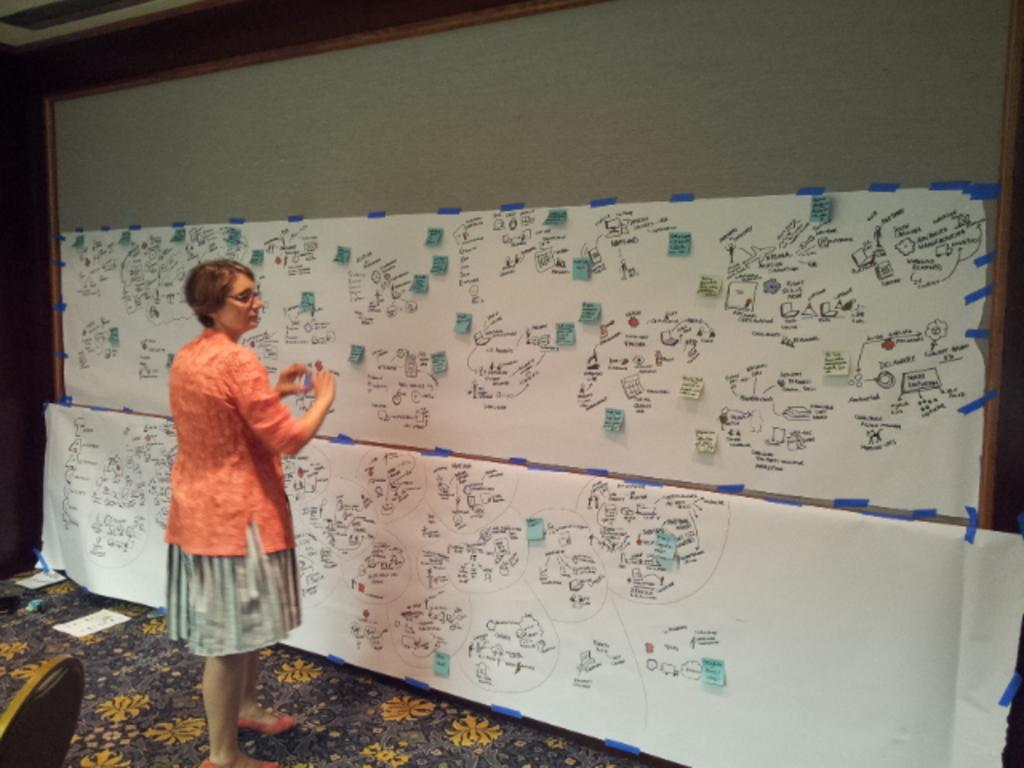Who is present in the image? There is a woman in the image. What is the woman standing in front of? The woman is standing in front of a board. What can be seen on the board? There are words written on the board and papers stuck to it. What is visible behind the woman? There is a chair visible behind the woman. How many eyes can be seen on the board in the image? There are no eyes present on the board in the image. What type of part is being discussed in the image? There is no specific part being discussed in the image; it features a woman standing in front of a board with words and papers. 